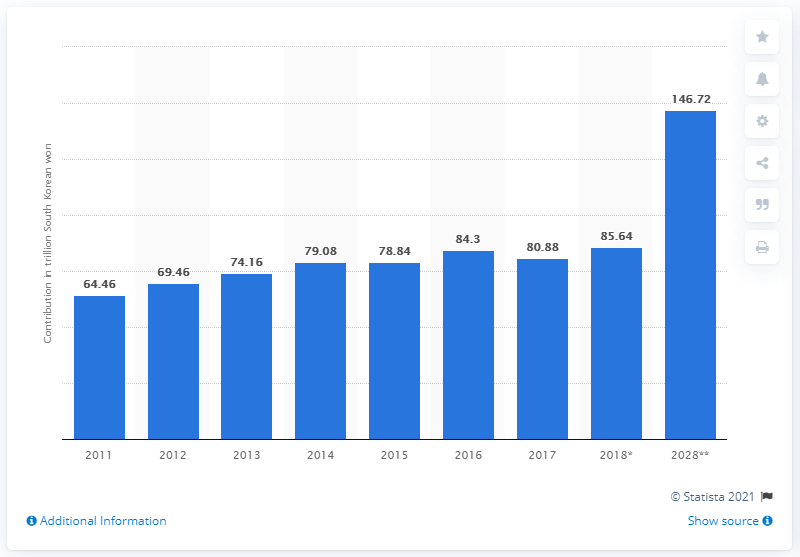Specify some key components in this picture. In 2017, the total contribution of travel and tourism to South Korea's Gross Domestic Product (GDP) was 80.88. 